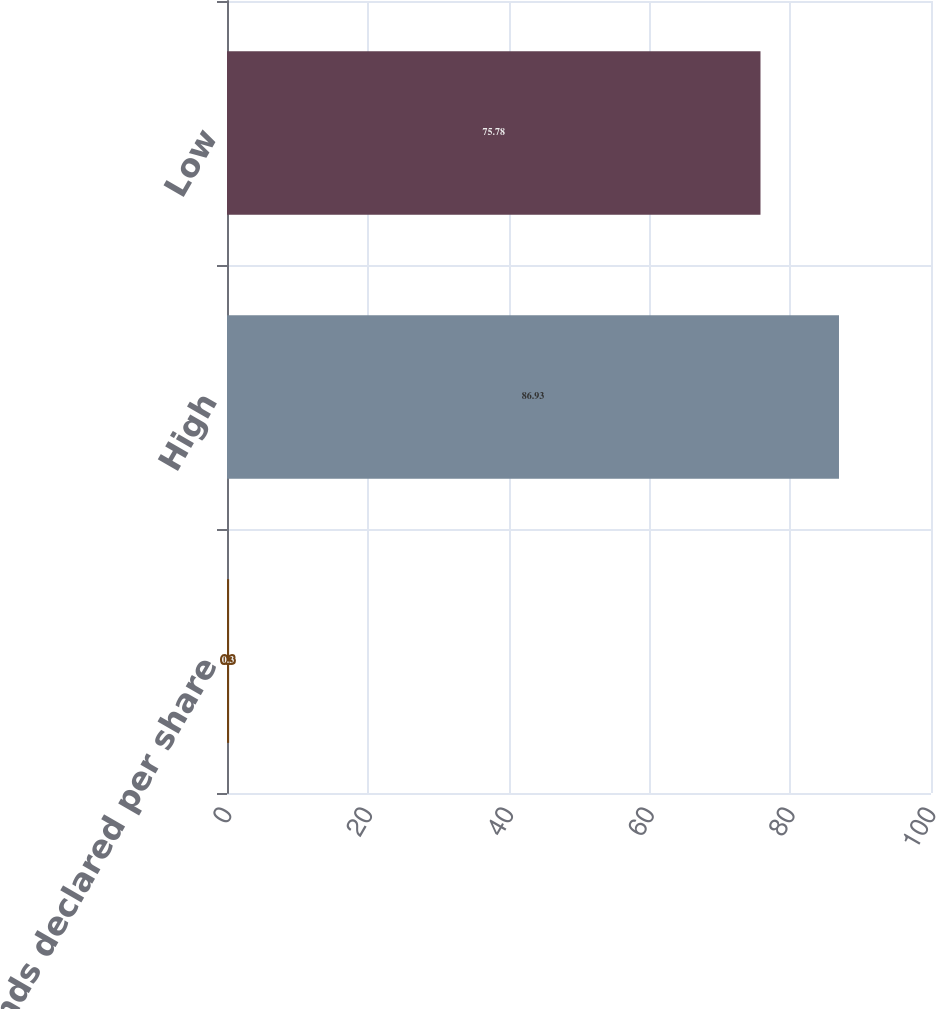Convert chart. <chart><loc_0><loc_0><loc_500><loc_500><bar_chart><fcel>Dividends declared per share<fcel>High<fcel>Low<nl><fcel>0.3<fcel>86.93<fcel>75.78<nl></chart> 